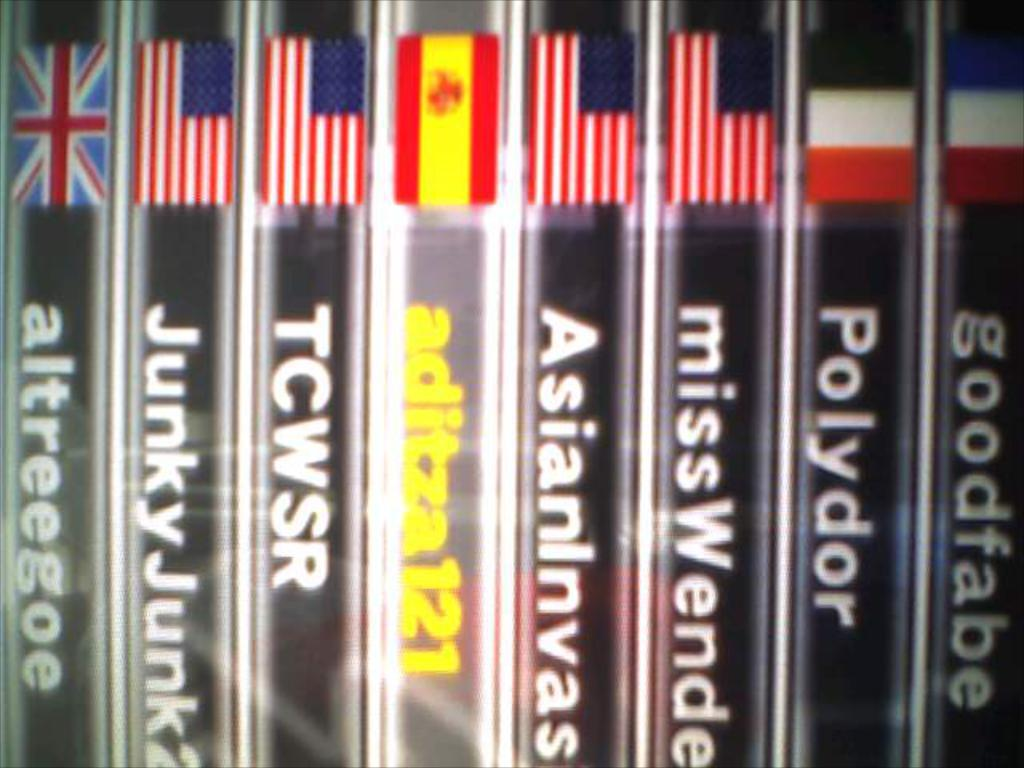Provide a one-sentence caption for the provided image. Book for "missWende" between some other books with flags on it. 